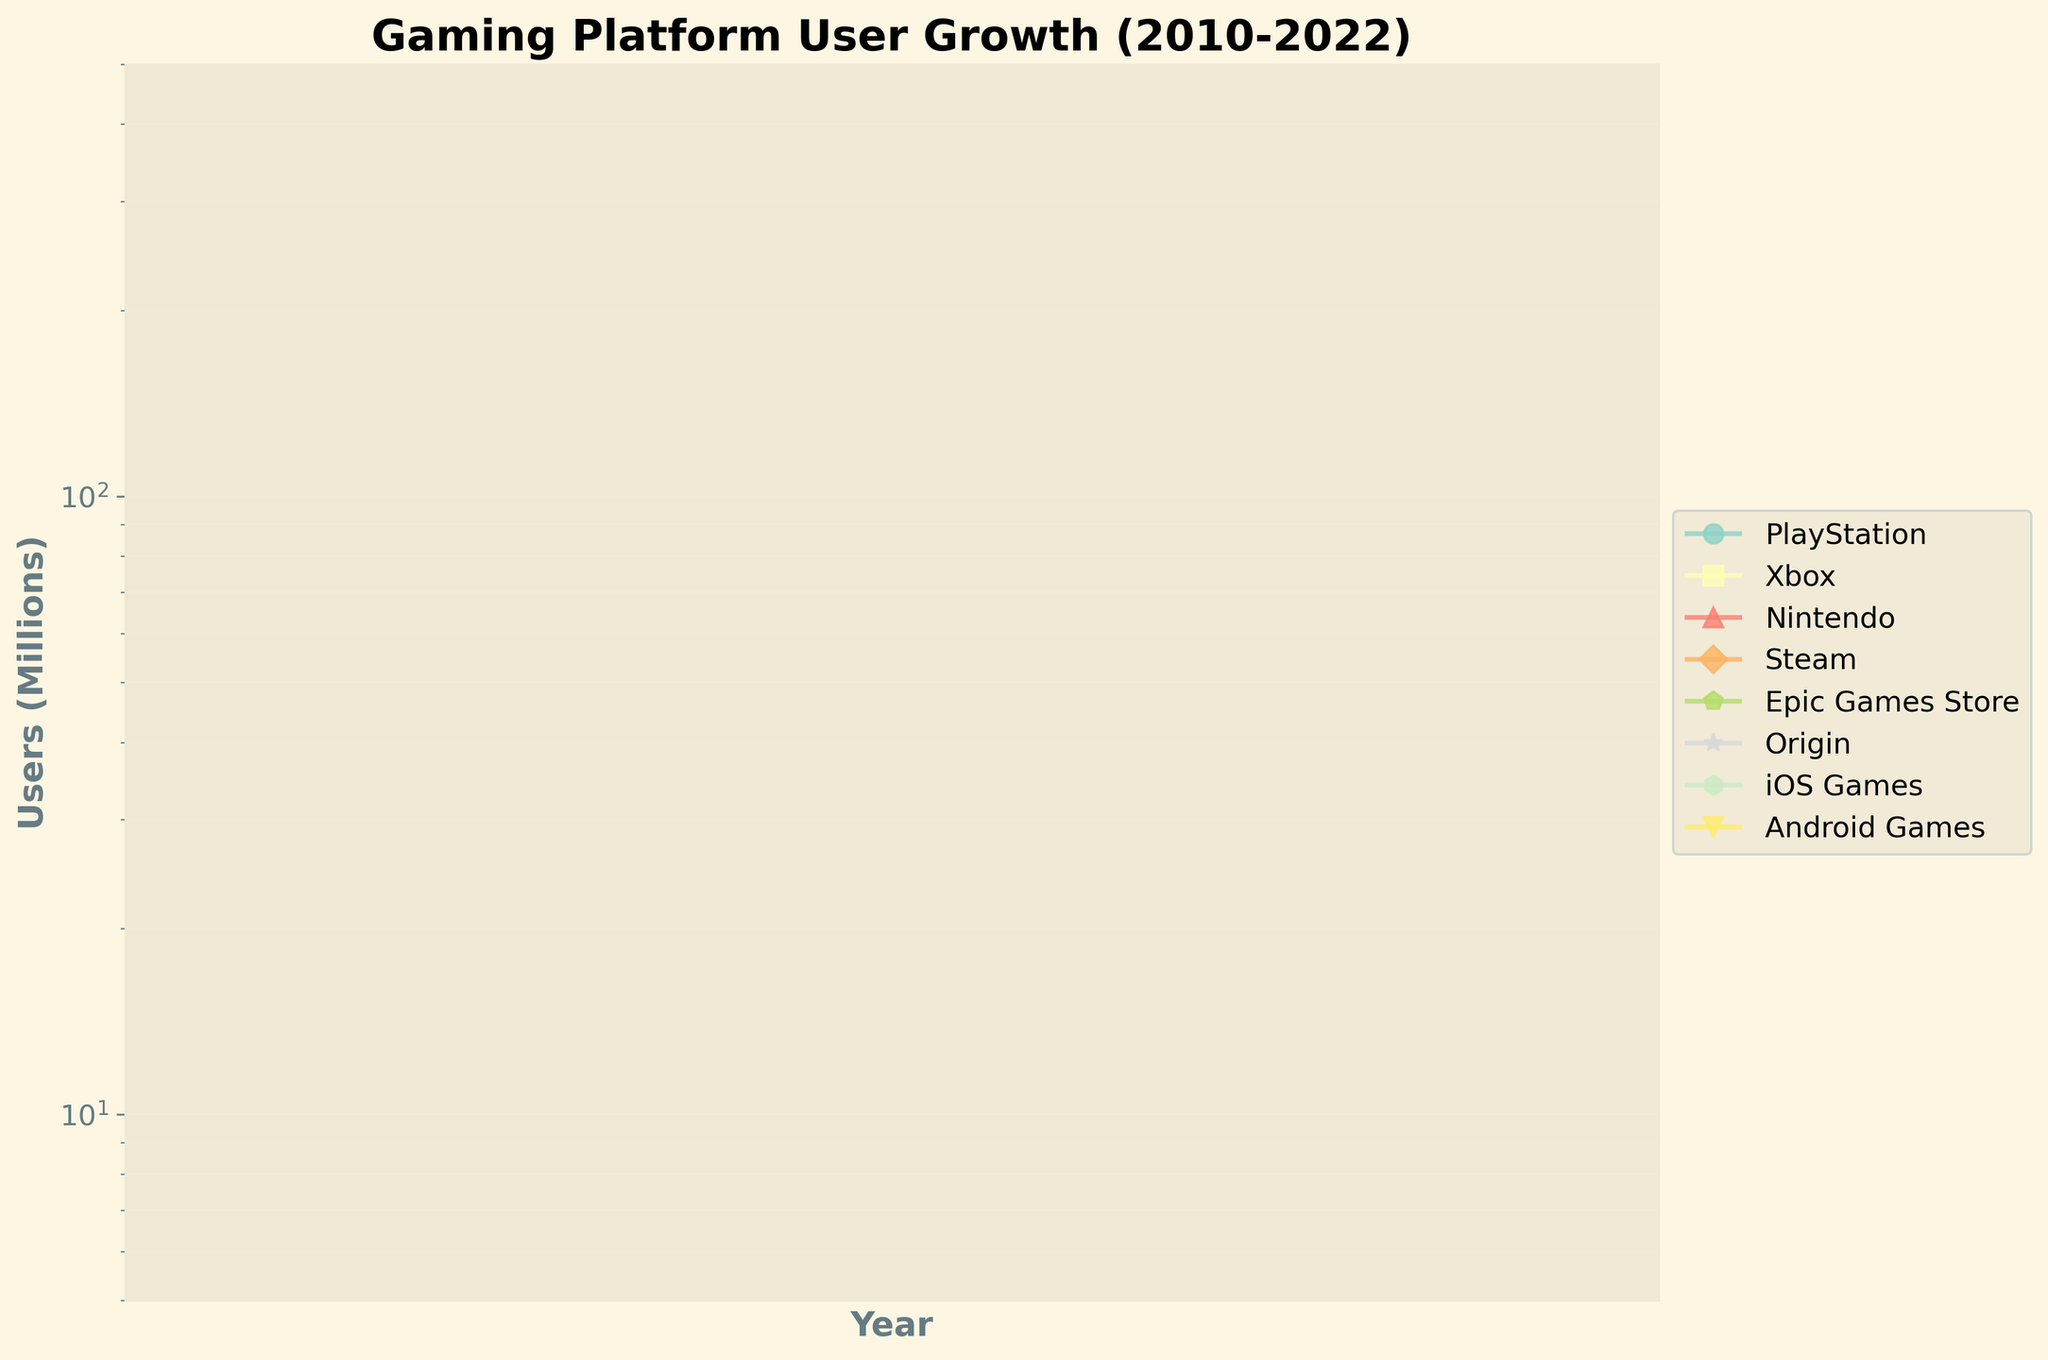When does PlayStation first reach 150 million users according to the plot? Locate the PlayStation line on the plot and find the point where the user count first hits 150 million. Check corresponding year on x-axis.
Answer: 2016 In which years did Android Games surpass 300 million users? Identify the Android Games line and find the points where the user count exceeds 300 million. Check corresponding years on x-axis.
Answer: 2020, 2022 By how much did the number of users for iOS Games increase from 2010 to 2022? Locate the iOS Games line, read the user numbers in 2010 and 2022, and subtract the 2010 value from the 2022 value.
Answer: 275 million Which platform showed the steepest growth from 2010 to 2022? Compare the slopes of the lines for each platform over the years. The steepest growth has the sharpest incline.
Answer: Android Games Which two gaming platforms had the least difference in user numbers in 2022? Locate the 2022 user count for each platform and find the two platforms with the closest user numbers.
Answer: Epic Games Store and Steam How many millions of users did Nintendo gain between 2010 and 2022? Locate the Nintendo line, read the user numbers in 2010 and 2022, and subtract the 2010 value from the 2022 value.
Answer: 155 million Which platform had more users in 2014, Xbox or PlayStation, and by how much? Locate the 2014 user counts for Xbox and PlayStation, then subtract the Xbox value from the PlayStation value.
Answer: PlayStation, by 30 million In what year did Origin first reach 50 million users? Locate the Origin line on the plot and find the point where the user count first hits 50 million. Check the corresponding year on the x-axis.
Answer: 2016 Among the mobile gaming platforms, which saw a higher total growth from 2010 to 2022? Add up total growth for iOS Games and Android Games by subtracting 2010 values from 2022 for each, then compare.
Answer: Android Games Is there any platform that had more than one million users every recorded year? Check each line to verify if any platform consistently stayed above one million users across all displayed years.
Answer: Yes 